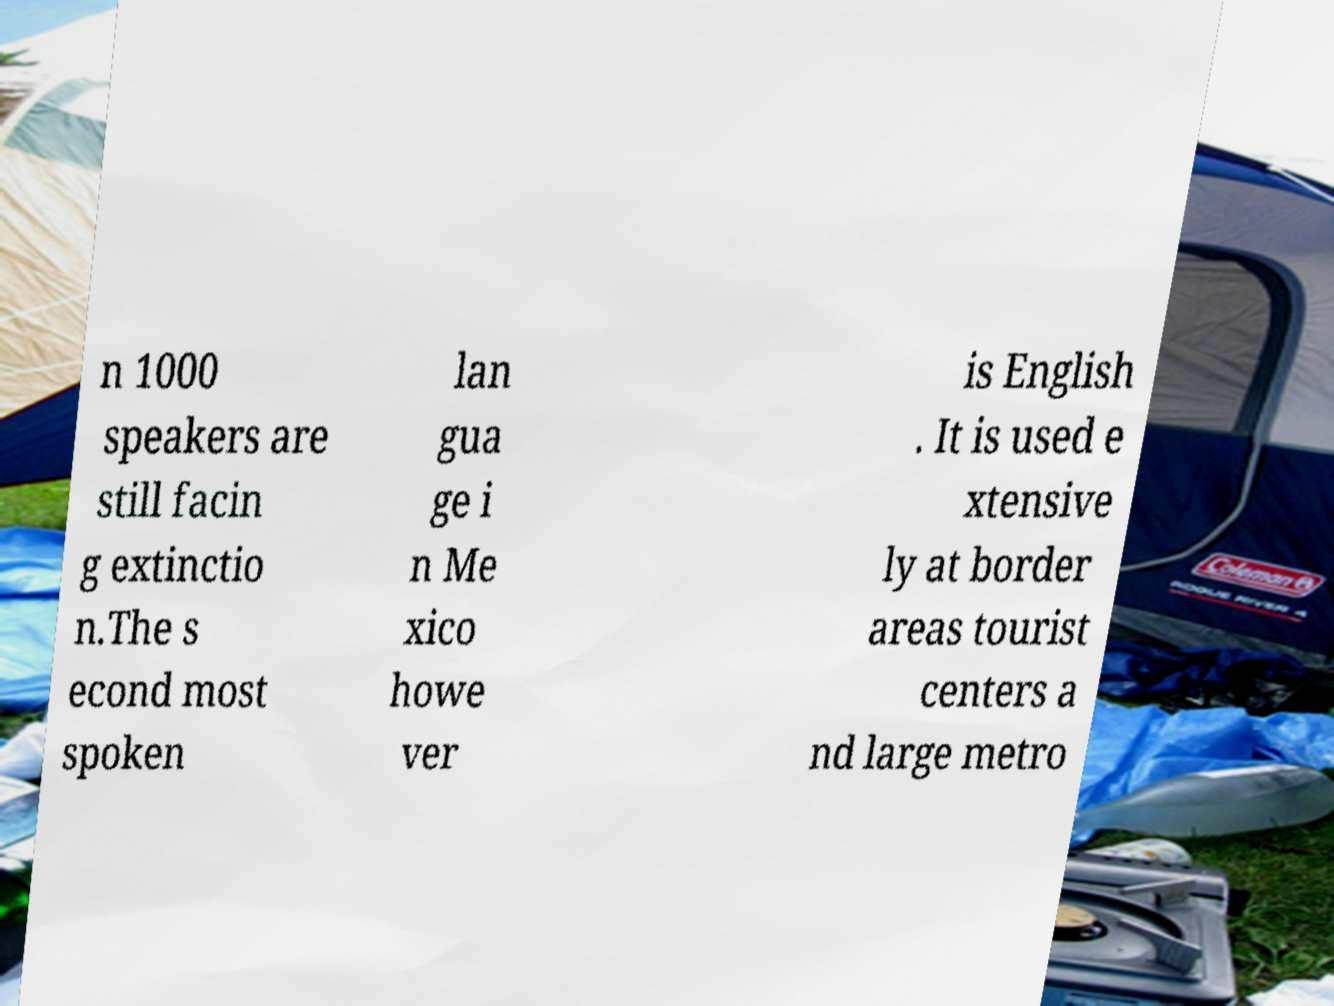Please identify and transcribe the text found in this image. n 1000 speakers are still facin g extinctio n.The s econd most spoken lan gua ge i n Me xico howe ver is English . It is used e xtensive ly at border areas tourist centers a nd large metro 